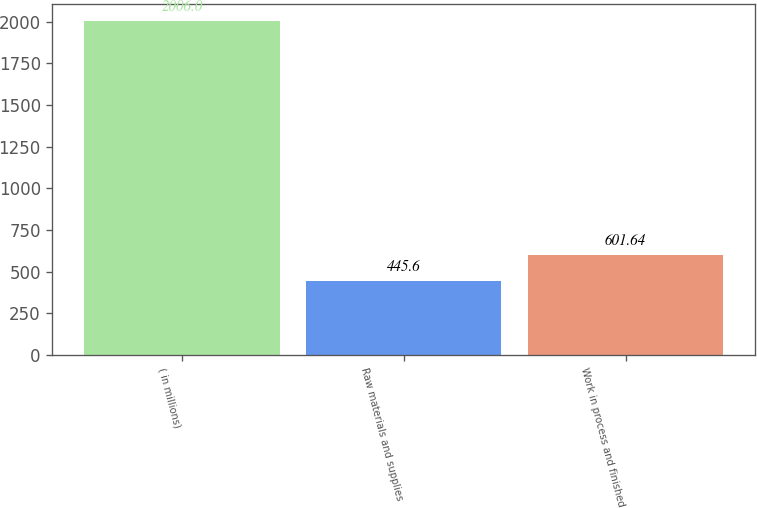Convert chart. <chart><loc_0><loc_0><loc_500><loc_500><bar_chart><fcel>( in millions)<fcel>Raw materials and supplies<fcel>Work in process and finished<nl><fcel>2006<fcel>445.6<fcel>601.64<nl></chart> 